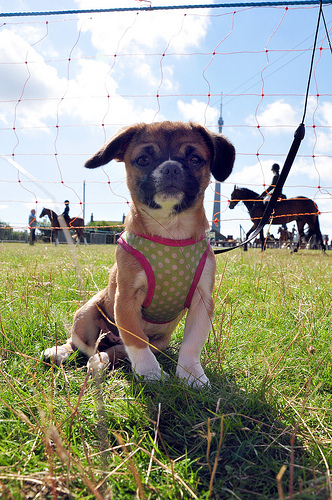<image>
Can you confirm if the net is behind the dog? Yes. From this viewpoint, the net is positioned behind the dog, with the dog partially or fully occluding the net. 